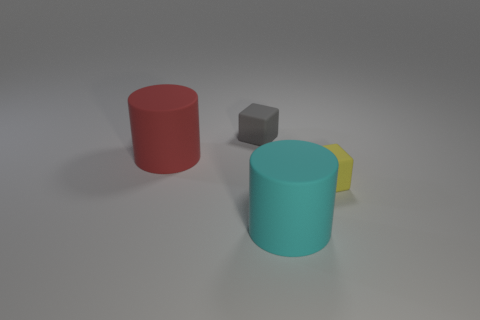What color is the other big object that is the same shape as the red rubber thing?
Provide a succinct answer. Cyan. There is a object that is both behind the cyan object and right of the gray block; what is its material?
Ensure brevity in your answer.  Rubber. Does the matte cylinder that is right of the gray matte thing have the same size as the yellow rubber block?
Ensure brevity in your answer.  No. What is the material of the big cyan cylinder?
Provide a succinct answer. Rubber. What is the color of the tiny matte thing that is in front of the gray cube?
Your answer should be compact. Yellow. What number of small objects are either cyan matte cylinders or red cylinders?
Your response must be concise. 0. There is a thing to the right of the big cyan matte cylinder; does it have the same color as the big cylinder right of the small gray matte block?
Ensure brevity in your answer.  No. How many brown objects are either small blocks or large cylinders?
Ensure brevity in your answer.  0. Does the small gray matte object have the same shape as the tiny rubber thing that is right of the tiny gray matte block?
Provide a succinct answer. Yes. There is a large cyan rubber object; what shape is it?
Ensure brevity in your answer.  Cylinder. 